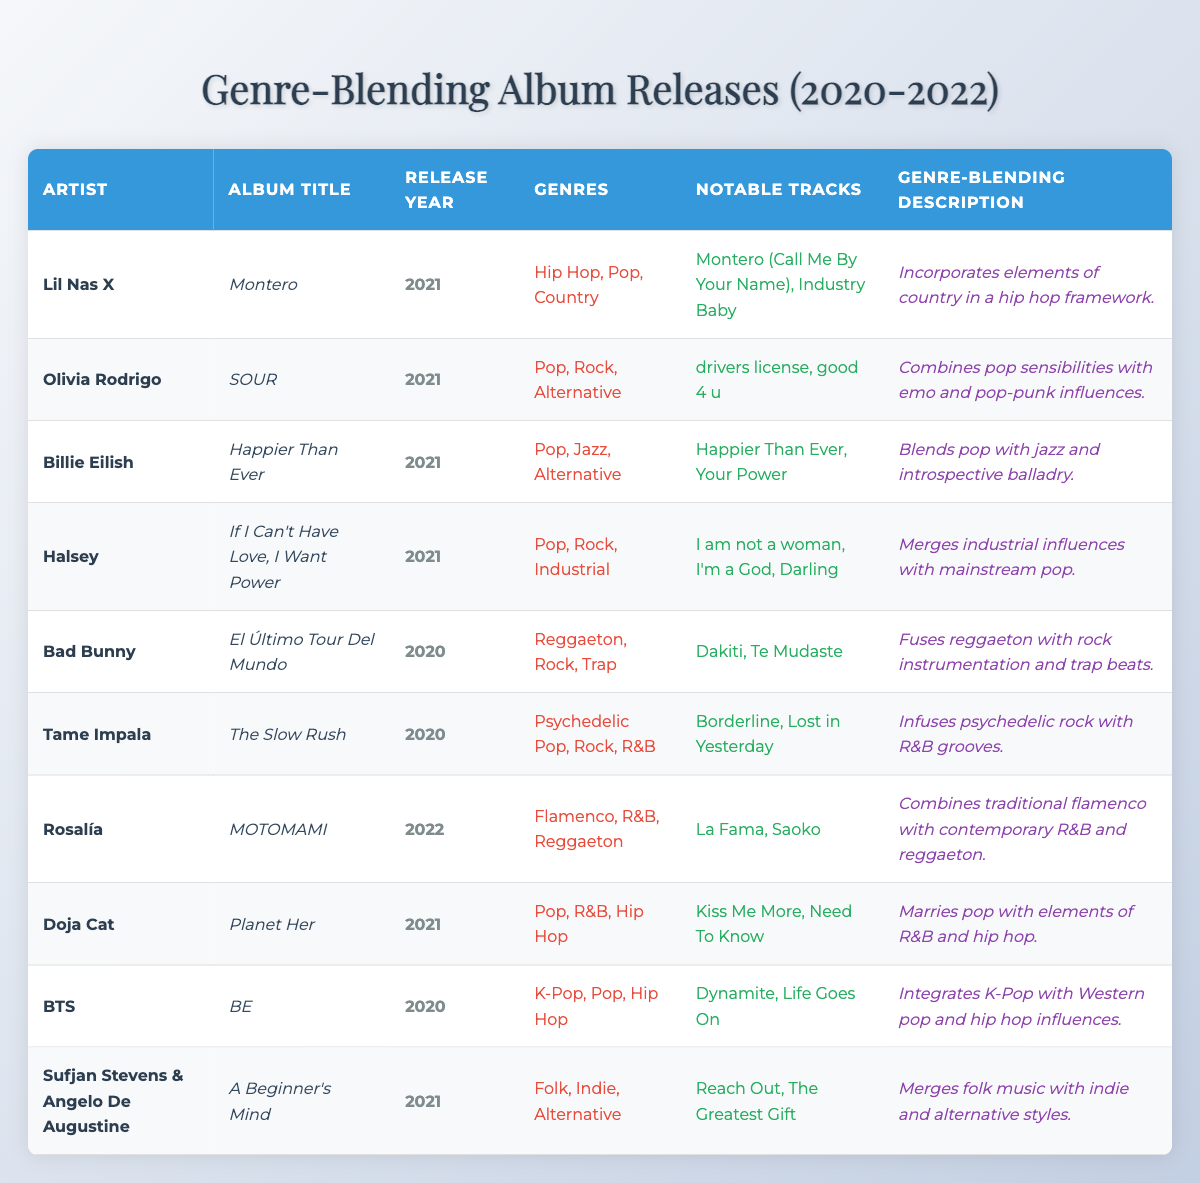What is the release year of "Montero" by Lil Nas X? The album "Montero" is listed in the table with its associated release year, which is stated as 2021.
Answer: 2021 Which artist released "SOUR"? In the table, "SOUR" is linked to the artist Olivia Rodrigo as indicated in the respective row.
Answer: Olivia Rodrigo How many albums were released by artists in 2021? By counting the rows corresponding to the release year 2021 in the table, there are four albums released that year.
Answer: 4 What genres are associated with Billie Eilish's album "Happier Than Ever"? In the table, the genres listed for the album "Happier Than Ever" are directly mentioned as Pop, Jazz, and Alternative.
Answer: Pop, Jazz, Alternative True or False: "El Último Tour Del Mundo" includes traditional Flamenco influences. Looking at the genres for "El Último Tour Del Mundo," it is classified as Reggaeton, Rock, and Trap, with no mention of Flamenco, making the statement false.
Answer: False Which artist's album blends Pop with elements of R&B and Hip Hop? By checking the descriptions in the table, Doja Cat's album "Planet Her" explicitly mentions marrying pop with R&B and hip hop elements.
Answer: Doja Cat How many genre influences can be found in "MOTOMAMI" by Rosalía? The table shows the genres for "MOTOMAMI" as Flamenco, R&B, and Reggaeton, which makes a total of three genre influences.
Answer: 3 Compare the notable tracks between "drivers license" and "Dakiti". Which one has more notable tracks? The notable tracks for "drivers license" (Olivia Rodrigo) is one track and for "Dakiti" (Bad Bunny) it also shows one track. Both have the same number of notable tracks.
Answer: They have the same number What is the common genre between Halsey and Billie Eilish's albums? The table indicates both albums have Pop as a common genre in their genre listings.
Answer: Pop Which album incorporates elements of country in a hip hop framework? According to the genre-blending description for "Montero" by Lil Nas X, it combines country elements with hip hop.
Answer: Montero 